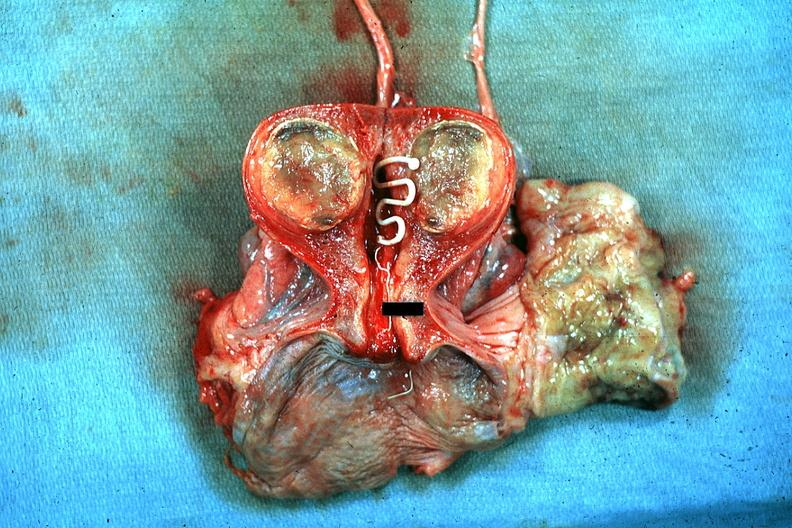does this image show excellent plastic coil with deep red endometrium and degenerating mural myoma?
Answer the question using a single word or phrase. Yes 